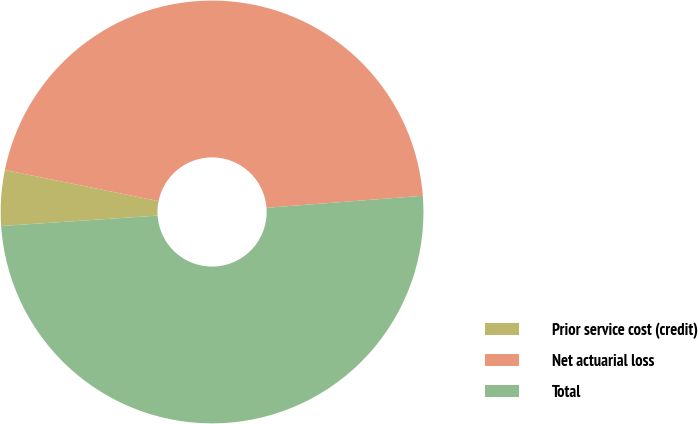<chart> <loc_0><loc_0><loc_500><loc_500><pie_chart><fcel>Prior service cost (credit)<fcel>Net actuarial loss<fcel>Total<nl><fcel>4.24%<fcel>45.6%<fcel>50.16%<nl></chart> 